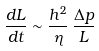Convert formula to latex. <formula><loc_0><loc_0><loc_500><loc_500>\frac { d L } { d t } \sim \frac { h ^ { 2 } } { \eta } \, \frac { \Delta p } { L }</formula> 